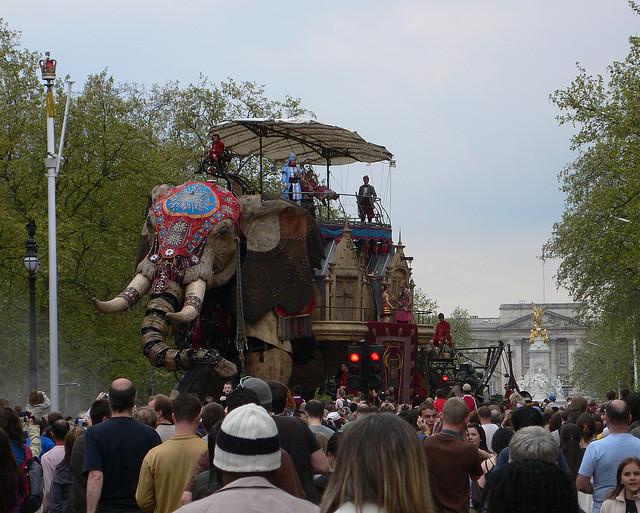How many people are there?
Answer briefly. 100. What is the object in the scene?
Give a very brief answer. Elephant. What ethnicity is the man on the elephant?
Be succinct. Indian. Is there a gold statue in the background?
Write a very short answer. Yes. How many trees are in this scene?
Give a very brief answer. 5. Is the elephant wearing a crown of flowers?
Short answer required. No. What animal is depicted in this picture?
Give a very brief answer. Elephant. What color are the elephants?
Keep it brief. Gray. What road are they on?
Quick response, please. India. What color is the elephant?
Answer briefly. Gray. Is this a parade?
Short answer required. Yes. 